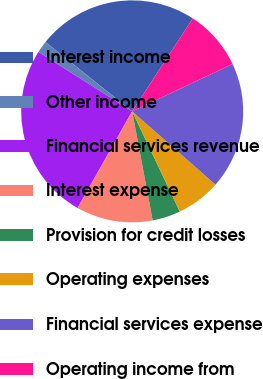<chart> <loc_0><loc_0><loc_500><loc_500><pie_chart><fcel>Interest income<fcel>Other income<fcel>Financial services revenue<fcel>Interest expense<fcel>Provision for credit losses<fcel>Operating expenses<fcel>Financial services expense<fcel>Operating income from<nl><fcel>23.46%<fcel>1.75%<fcel>25.81%<fcel>11.14%<fcel>4.1%<fcel>6.45%<fcel>18.5%<fcel>8.79%<nl></chart> 